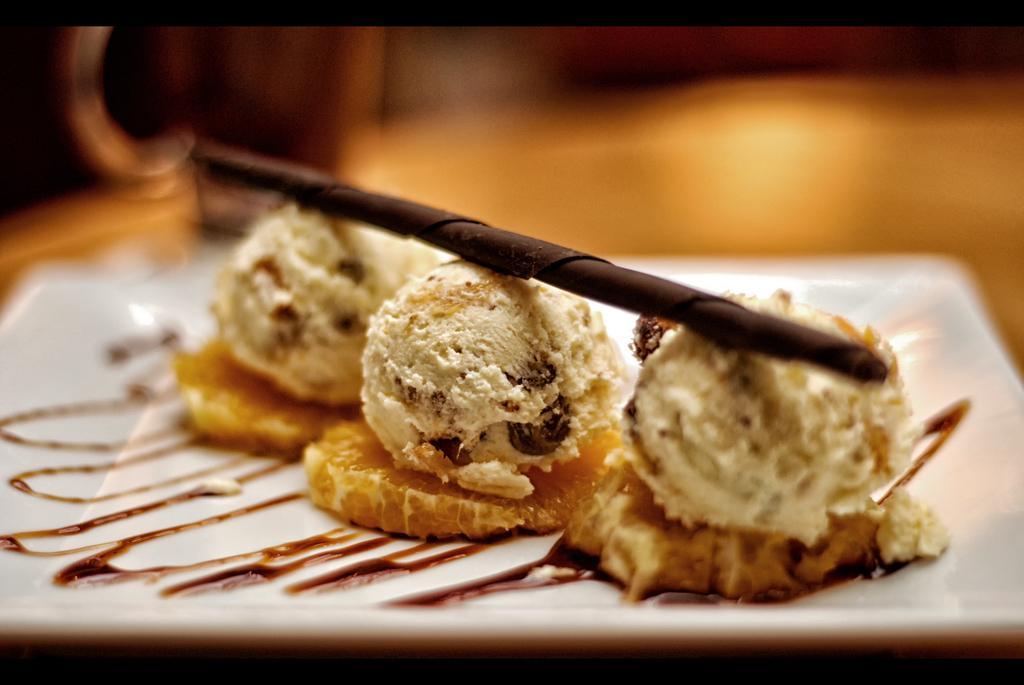How would you summarize this image in a sentence or two? In this picture there is food on the white plate. At the back the image is blurry. 